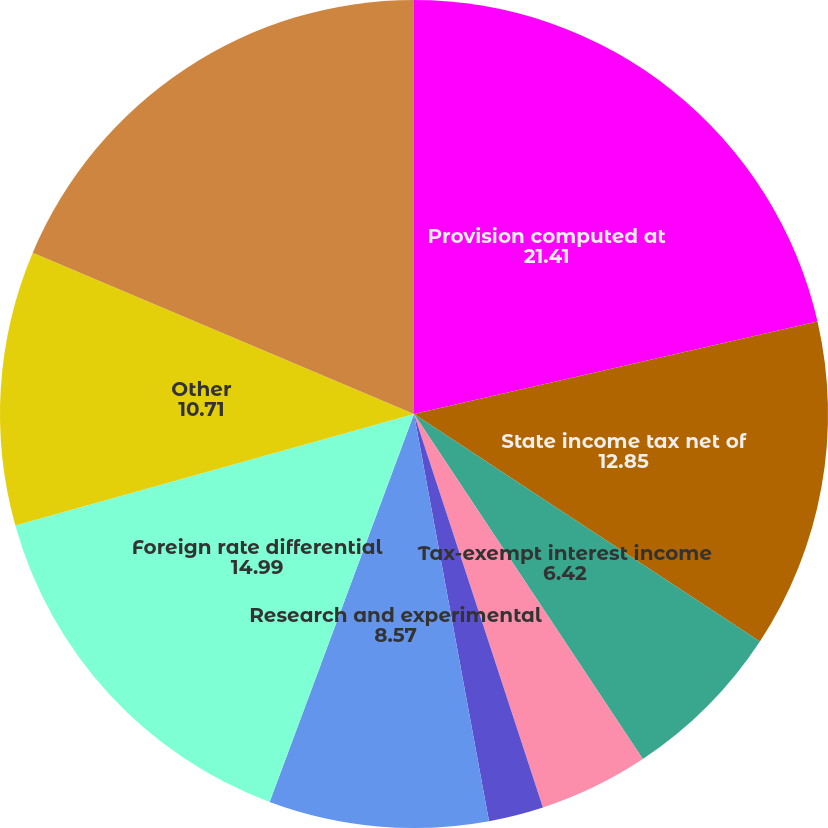<chart> <loc_0><loc_0><loc_500><loc_500><pie_chart><fcel>Provision computed at<fcel>State income tax net of<fcel>Asset impairment charge<fcel>Tax-exempt interest income<fcel>Acquisition related items<fcel>Domestic manufacturing<fcel>Research and experimental<fcel>Foreign rate differential<fcel>Other<fcel>Provision for income taxes<nl><fcel>21.41%<fcel>12.85%<fcel>0.0%<fcel>6.42%<fcel>4.28%<fcel>2.14%<fcel>8.57%<fcel>14.99%<fcel>10.71%<fcel>18.63%<nl></chart> 